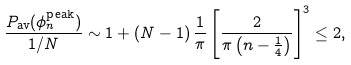<formula> <loc_0><loc_0><loc_500><loc_500>\frac { { P } _ { \text {av} } ( \phi ^ { \text {peak} } _ { n } ) } { 1 / N } \sim 1 + \left ( N - 1 \right ) \frac { 1 } { \pi } \left [ \frac { 2 } { \pi \left ( n - \frac { 1 } { 4 } \right ) } \right ] ^ { 3 } & \leq 2 ,</formula> 